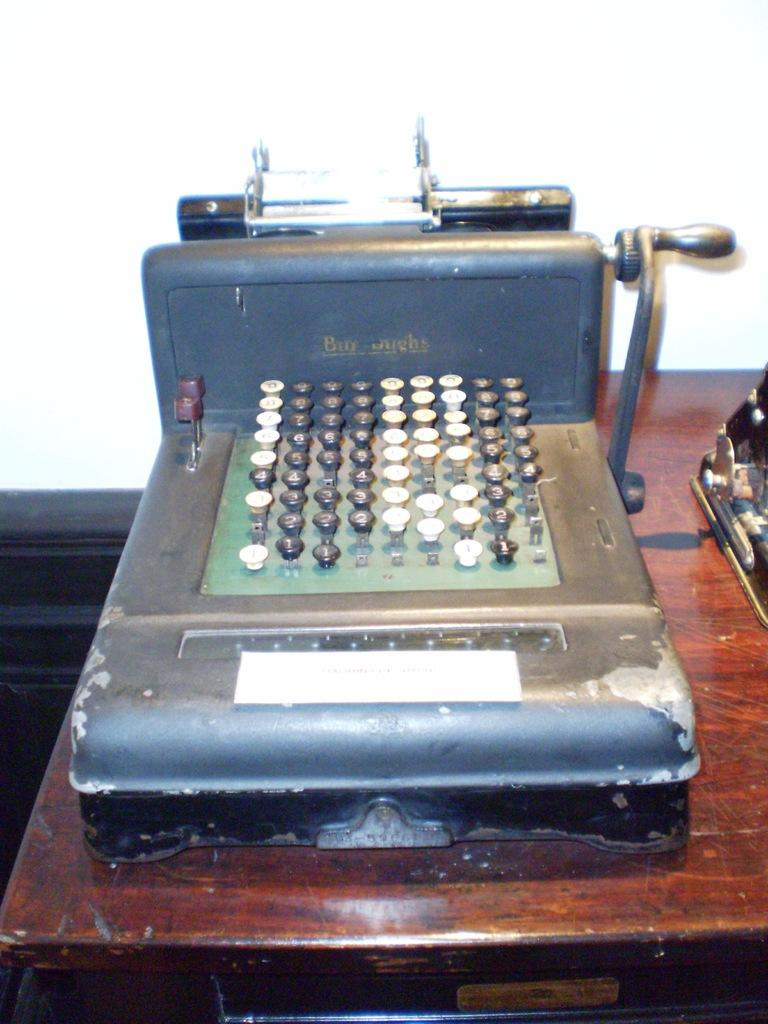What is located at the bottom of the image? There is a table at the bottom of the image. What is on the table in the image? There is a machine on the table. What is located at the top of the image? There is a wall at the top of the image. What is the name of the cave in the image? There is no cave present in the image. What type of magic is being performed by the machine in the image? There is no magic being performed by the machine in the image; it is simply a machine on a table. 